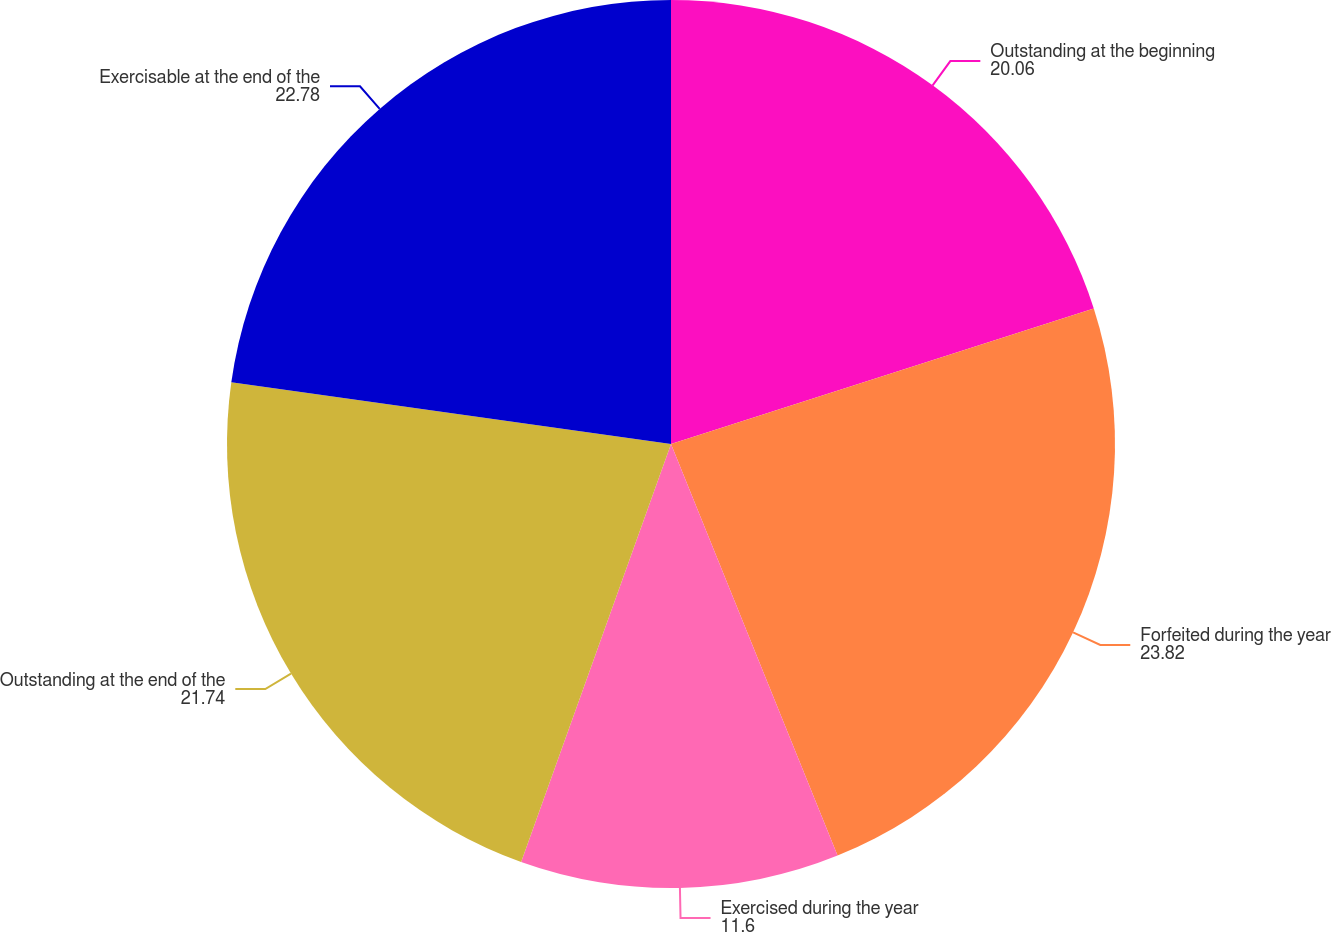<chart> <loc_0><loc_0><loc_500><loc_500><pie_chart><fcel>Outstanding at the beginning<fcel>Forfeited during the year<fcel>Exercised during the year<fcel>Outstanding at the end of the<fcel>Exercisable at the end of the<nl><fcel>20.06%<fcel>23.82%<fcel>11.6%<fcel>21.74%<fcel>22.78%<nl></chart> 